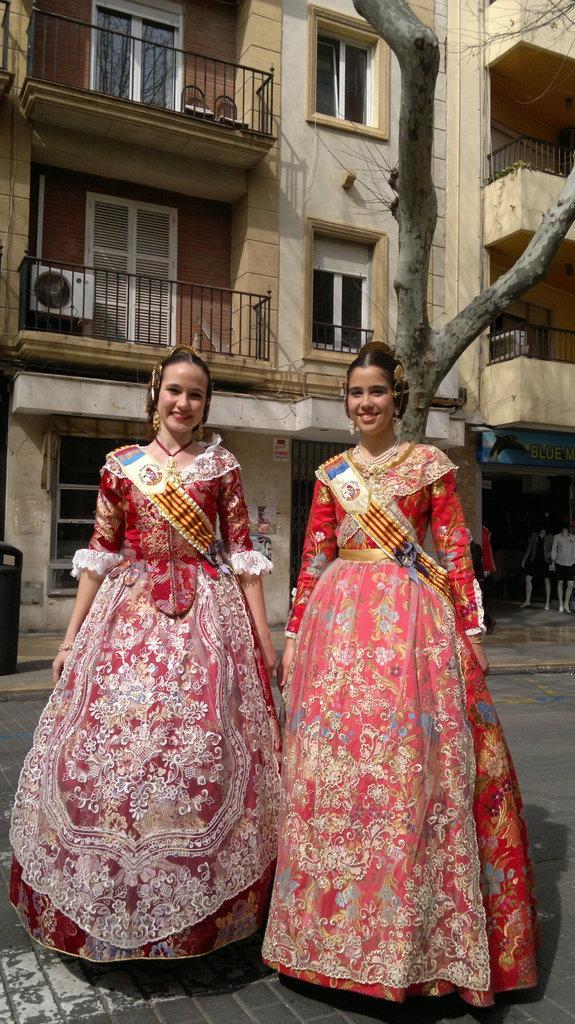How would you summarize this image in a sentence or two? In this picture we can see two women standing on the road. Behind the women, there are buildings with windows and balconies and there is a tree trunk and a name board. On the right side of the image, there are mannequins in a shop. On the right side of the image, there is an object on the walkway. There is an air conditioner outdoor unit in a balcony. At the top of the image, there are two chairs in another balcony. 